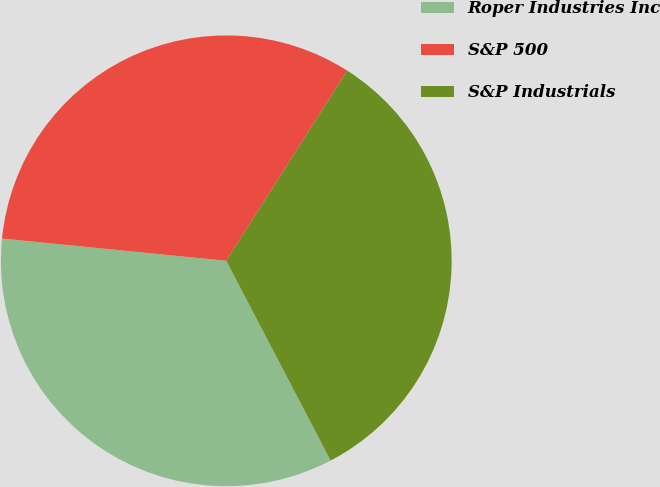Convert chart to OTSL. <chart><loc_0><loc_0><loc_500><loc_500><pie_chart><fcel>Roper Industries Inc<fcel>S&P 500<fcel>S&P Industrials<nl><fcel>34.24%<fcel>32.44%<fcel>33.32%<nl></chart> 